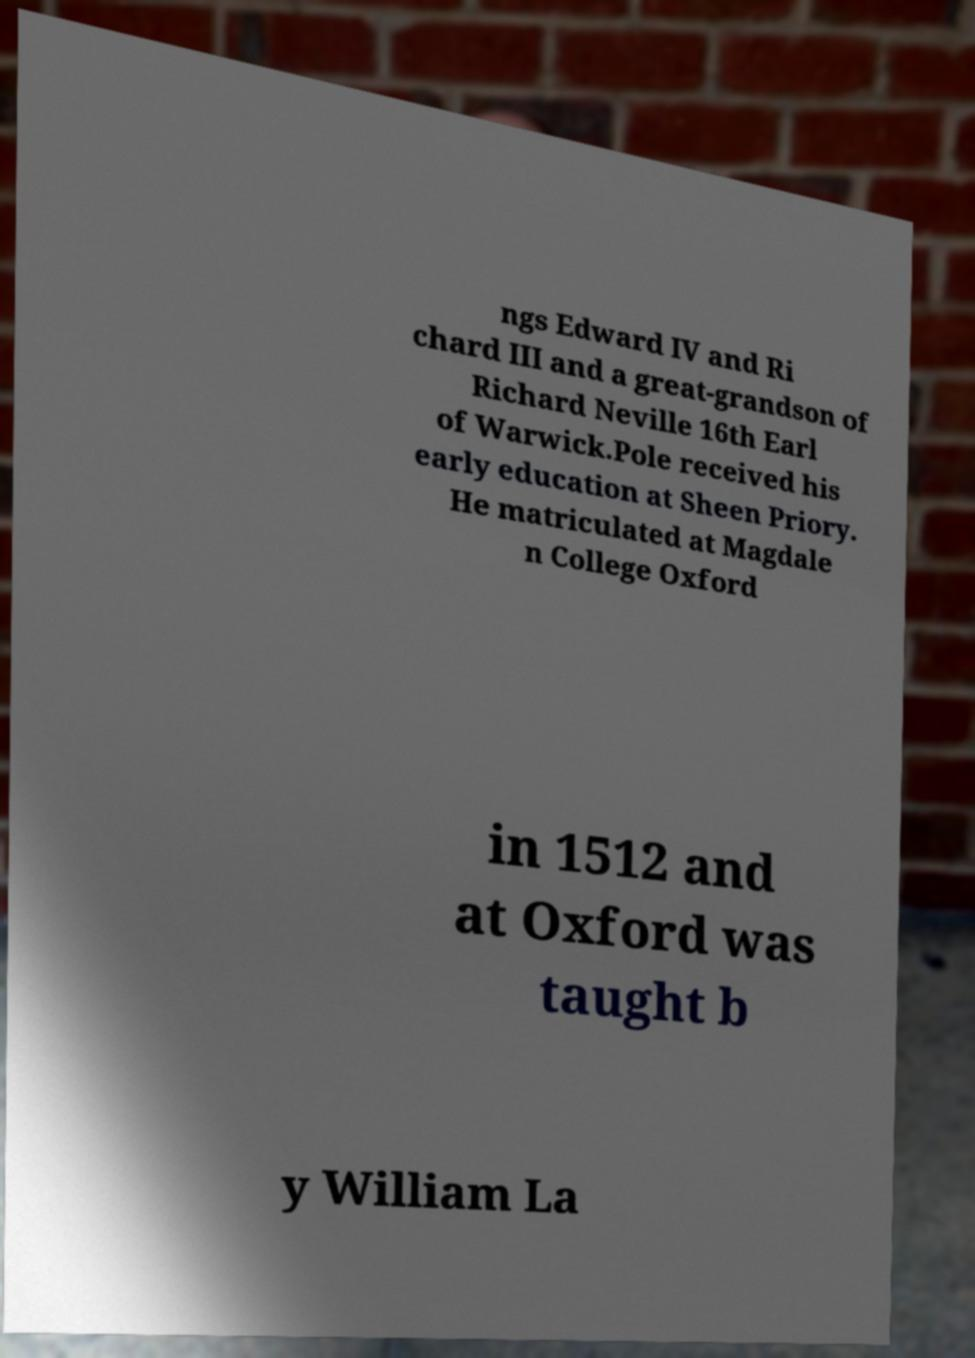I need the written content from this picture converted into text. Can you do that? ngs Edward IV and Ri chard III and a great-grandson of Richard Neville 16th Earl of Warwick.Pole received his early education at Sheen Priory. He matriculated at Magdale n College Oxford in 1512 and at Oxford was taught b y William La 